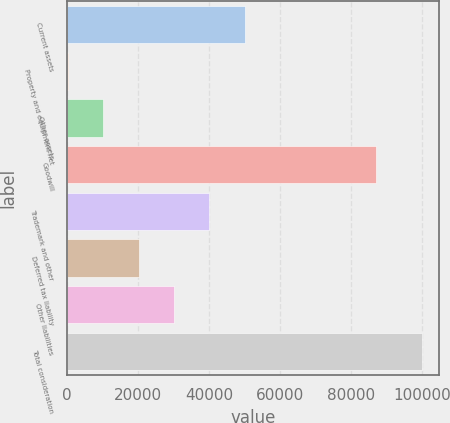<chart> <loc_0><loc_0><loc_500><loc_500><bar_chart><fcel>Current assets<fcel>Property and equipment net<fcel>Other assets<fcel>Goodwill<fcel>Trademark and other<fcel>Deferred tax liability<fcel>Other liabilities<fcel>Total consideration<nl><fcel>50076<fcel>207<fcel>10180.8<fcel>87004<fcel>40102.2<fcel>20154.6<fcel>30128.4<fcel>99945<nl></chart> 